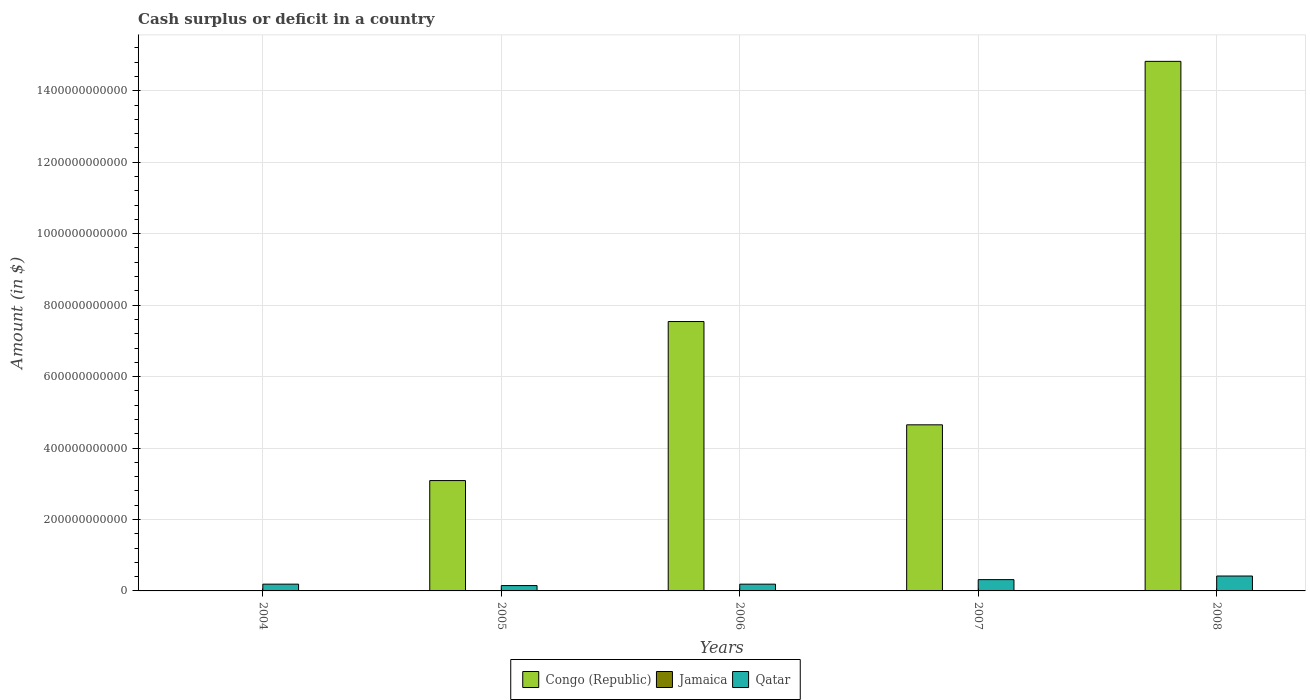Are the number of bars per tick equal to the number of legend labels?
Ensure brevity in your answer.  No. What is the amount of cash surplus or deficit in Qatar in 2006?
Offer a terse response. 1.89e+1. Across all years, what is the maximum amount of cash surplus or deficit in Qatar?
Your response must be concise. 4.17e+1. Across all years, what is the minimum amount of cash surplus or deficit in Qatar?
Your response must be concise. 1.49e+1. What is the total amount of cash surplus or deficit in Qatar in the graph?
Make the answer very short. 1.26e+11. What is the difference between the amount of cash surplus or deficit in Qatar in 2006 and that in 2007?
Provide a succinct answer. -1.27e+1. What is the difference between the amount of cash surplus or deficit in Jamaica in 2007 and the amount of cash surplus or deficit in Qatar in 2004?
Provide a succinct answer. -1.90e+1. In the year 2007, what is the difference between the amount of cash surplus or deficit in Congo (Republic) and amount of cash surplus or deficit in Qatar?
Provide a succinct answer. 4.33e+11. In how many years, is the amount of cash surplus or deficit in Congo (Republic) greater than 120000000000 $?
Offer a terse response. 4. What is the ratio of the amount of cash surplus or deficit in Qatar in 2004 to that in 2008?
Ensure brevity in your answer.  0.45. What is the difference between the highest and the second highest amount of cash surplus or deficit in Congo (Republic)?
Provide a succinct answer. 7.28e+11. What is the difference between the highest and the lowest amount of cash surplus or deficit in Qatar?
Your answer should be very brief. 2.68e+1. How many bars are there?
Provide a short and direct response. 9. How many years are there in the graph?
Your answer should be compact. 5. What is the difference between two consecutive major ticks on the Y-axis?
Ensure brevity in your answer.  2.00e+11. Are the values on the major ticks of Y-axis written in scientific E-notation?
Your response must be concise. No. Does the graph contain grids?
Ensure brevity in your answer.  Yes. Where does the legend appear in the graph?
Offer a very short reply. Bottom center. What is the title of the graph?
Offer a very short reply. Cash surplus or deficit in a country. Does "Bermuda" appear as one of the legend labels in the graph?
Offer a terse response. No. What is the label or title of the X-axis?
Keep it short and to the point. Years. What is the label or title of the Y-axis?
Offer a very short reply. Amount (in $). What is the Amount (in $) of Congo (Republic) in 2004?
Provide a succinct answer. 0. What is the Amount (in $) in Jamaica in 2004?
Your answer should be very brief. 0. What is the Amount (in $) of Qatar in 2004?
Offer a very short reply. 1.90e+1. What is the Amount (in $) in Congo (Republic) in 2005?
Provide a succinct answer. 3.09e+11. What is the Amount (in $) of Jamaica in 2005?
Give a very brief answer. 0. What is the Amount (in $) of Qatar in 2005?
Offer a very short reply. 1.49e+1. What is the Amount (in $) in Congo (Republic) in 2006?
Offer a terse response. 7.54e+11. What is the Amount (in $) in Qatar in 2006?
Keep it short and to the point. 1.89e+1. What is the Amount (in $) in Congo (Republic) in 2007?
Offer a terse response. 4.65e+11. What is the Amount (in $) of Jamaica in 2007?
Keep it short and to the point. 0. What is the Amount (in $) in Qatar in 2007?
Your response must be concise. 3.16e+1. What is the Amount (in $) in Congo (Republic) in 2008?
Offer a terse response. 1.48e+12. What is the Amount (in $) in Qatar in 2008?
Offer a terse response. 4.17e+1. Across all years, what is the maximum Amount (in $) in Congo (Republic)?
Provide a succinct answer. 1.48e+12. Across all years, what is the maximum Amount (in $) of Qatar?
Provide a succinct answer. 4.17e+1. Across all years, what is the minimum Amount (in $) in Qatar?
Keep it short and to the point. 1.49e+1. What is the total Amount (in $) in Congo (Republic) in the graph?
Offer a very short reply. 3.01e+12. What is the total Amount (in $) of Jamaica in the graph?
Give a very brief answer. 0. What is the total Amount (in $) of Qatar in the graph?
Your answer should be very brief. 1.26e+11. What is the difference between the Amount (in $) of Qatar in 2004 and that in 2005?
Offer a terse response. 4.04e+09. What is the difference between the Amount (in $) in Qatar in 2004 and that in 2006?
Make the answer very short. 4.60e+07. What is the difference between the Amount (in $) in Qatar in 2004 and that in 2007?
Keep it short and to the point. -1.27e+1. What is the difference between the Amount (in $) of Qatar in 2004 and that in 2008?
Your response must be concise. -2.27e+1. What is the difference between the Amount (in $) of Congo (Republic) in 2005 and that in 2006?
Your response must be concise. -4.45e+11. What is the difference between the Amount (in $) in Qatar in 2005 and that in 2006?
Ensure brevity in your answer.  -4.00e+09. What is the difference between the Amount (in $) of Congo (Republic) in 2005 and that in 2007?
Your answer should be compact. -1.56e+11. What is the difference between the Amount (in $) in Qatar in 2005 and that in 2007?
Make the answer very short. -1.67e+1. What is the difference between the Amount (in $) of Congo (Republic) in 2005 and that in 2008?
Offer a terse response. -1.17e+12. What is the difference between the Amount (in $) of Qatar in 2005 and that in 2008?
Ensure brevity in your answer.  -2.68e+1. What is the difference between the Amount (in $) of Congo (Republic) in 2006 and that in 2007?
Ensure brevity in your answer.  2.89e+11. What is the difference between the Amount (in $) in Qatar in 2006 and that in 2007?
Ensure brevity in your answer.  -1.27e+1. What is the difference between the Amount (in $) in Congo (Republic) in 2006 and that in 2008?
Your answer should be very brief. -7.28e+11. What is the difference between the Amount (in $) in Qatar in 2006 and that in 2008?
Make the answer very short. -2.28e+1. What is the difference between the Amount (in $) of Congo (Republic) in 2007 and that in 2008?
Your answer should be compact. -1.02e+12. What is the difference between the Amount (in $) of Qatar in 2007 and that in 2008?
Offer a very short reply. -1.01e+1. What is the difference between the Amount (in $) of Congo (Republic) in 2005 and the Amount (in $) of Qatar in 2006?
Offer a terse response. 2.90e+11. What is the difference between the Amount (in $) of Congo (Republic) in 2005 and the Amount (in $) of Qatar in 2007?
Give a very brief answer. 2.77e+11. What is the difference between the Amount (in $) of Congo (Republic) in 2005 and the Amount (in $) of Qatar in 2008?
Your answer should be compact. 2.67e+11. What is the difference between the Amount (in $) of Congo (Republic) in 2006 and the Amount (in $) of Qatar in 2007?
Give a very brief answer. 7.23e+11. What is the difference between the Amount (in $) of Congo (Republic) in 2006 and the Amount (in $) of Qatar in 2008?
Your response must be concise. 7.12e+11. What is the difference between the Amount (in $) of Congo (Republic) in 2007 and the Amount (in $) of Qatar in 2008?
Your answer should be compact. 4.23e+11. What is the average Amount (in $) of Congo (Republic) per year?
Ensure brevity in your answer.  6.02e+11. What is the average Amount (in $) in Qatar per year?
Provide a succinct answer. 2.52e+1. In the year 2005, what is the difference between the Amount (in $) of Congo (Republic) and Amount (in $) of Qatar?
Your response must be concise. 2.94e+11. In the year 2006, what is the difference between the Amount (in $) of Congo (Republic) and Amount (in $) of Qatar?
Your answer should be compact. 7.35e+11. In the year 2007, what is the difference between the Amount (in $) of Congo (Republic) and Amount (in $) of Qatar?
Ensure brevity in your answer.  4.33e+11. In the year 2008, what is the difference between the Amount (in $) in Congo (Republic) and Amount (in $) in Qatar?
Keep it short and to the point. 1.44e+12. What is the ratio of the Amount (in $) of Qatar in 2004 to that in 2005?
Your response must be concise. 1.27. What is the ratio of the Amount (in $) in Qatar in 2004 to that in 2007?
Your answer should be very brief. 0.6. What is the ratio of the Amount (in $) of Qatar in 2004 to that in 2008?
Give a very brief answer. 0.45. What is the ratio of the Amount (in $) in Congo (Republic) in 2005 to that in 2006?
Provide a short and direct response. 0.41. What is the ratio of the Amount (in $) of Qatar in 2005 to that in 2006?
Provide a short and direct response. 0.79. What is the ratio of the Amount (in $) in Congo (Republic) in 2005 to that in 2007?
Provide a succinct answer. 0.66. What is the ratio of the Amount (in $) in Qatar in 2005 to that in 2007?
Make the answer very short. 0.47. What is the ratio of the Amount (in $) of Congo (Republic) in 2005 to that in 2008?
Offer a very short reply. 0.21. What is the ratio of the Amount (in $) in Qatar in 2005 to that in 2008?
Give a very brief answer. 0.36. What is the ratio of the Amount (in $) in Congo (Republic) in 2006 to that in 2007?
Ensure brevity in your answer.  1.62. What is the ratio of the Amount (in $) in Qatar in 2006 to that in 2007?
Make the answer very short. 0.6. What is the ratio of the Amount (in $) in Congo (Republic) in 2006 to that in 2008?
Offer a terse response. 0.51. What is the ratio of the Amount (in $) in Qatar in 2006 to that in 2008?
Make the answer very short. 0.45. What is the ratio of the Amount (in $) of Congo (Republic) in 2007 to that in 2008?
Provide a succinct answer. 0.31. What is the ratio of the Amount (in $) of Qatar in 2007 to that in 2008?
Offer a terse response. 0.76. What is the difference between the highest and the second highest Amount (in $) of Congo (Republic)?
Your answer should be very brief. 7.28e+11. What is the difference between the highest and the second highest Amount (in $) in Qatar?
Offer a terse response. 1.01e+1. What is the difference between the highest and the lowest Amount (in $) in Congo (Republic)?
Offer a terse response. 1.48e+12. What is the difference between the highest and the lowest Amount (in $) of Qatar?
Ensure brevity in your answer.  2.68e+1. 